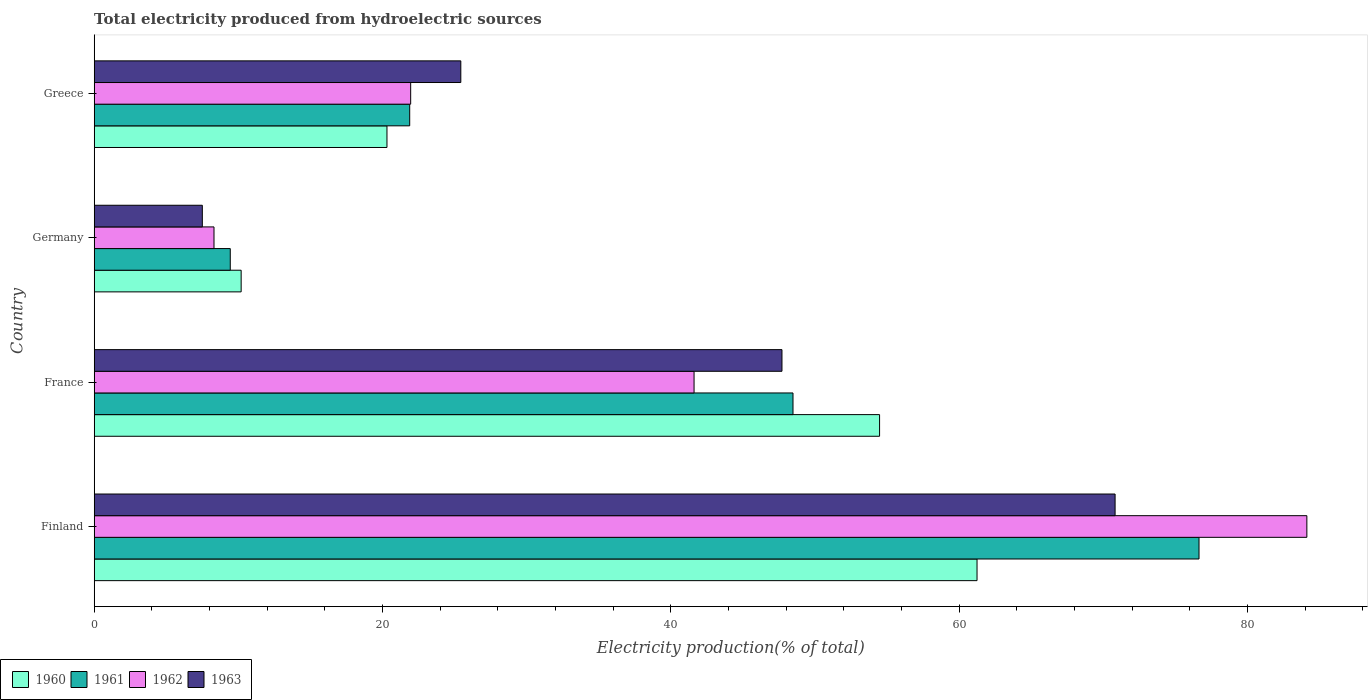How many different coloured bars are there?
Give a very brief answer. 4. Are the number of bars on each tick of the Y-axis equal?
Your response must be concise. Yes. What is the total electricity produced in 1963 in France?
Your answer should be compact. 47.7. Across all countries, what is the maximum total electricity produced in 1962?
Offer a very short reply. 84.11. Across all countries, what is the minimum total electricity produced in 1960?
Offer a very short reply. 10.19. In which country was the total electricity produced in 1961 minimum?
Offer a terse response. Germany. What is the total total electricity produced in 1963 in the graph?
Ensure brevity in your answer.  151.44. What is the difference between the total electricity produced in 1960 in Germany and that in Greece?
Your answer should be very brief. -10.11. What is the difference between the total electricity produced in 1961 in Germany and the total electricity produced in 1960 in Finland?
Make the answer very short. -51.8. What is the average total electricity produced in 1961 per country?
Ensure brevity in your answer.  39.1. What is the difference between the total electricity produced in 1963 and total electricity produced in 1961 in France?
Provide a succinct answer. -0.77. In how many countries, is the total electricity produced in 1961 greater than 72 %?
Make the answer very short. 1. What is the ratio of the total electricity produced in 1963 in France to that in Greece?
Offer a very short reply. 1.88. Is the total electricity produced in 1962 in France less than that in Germany?
Provide a succinct answer. No. What is the difference between the highest and the second highest total electricity produced in 1963?
Make the answer very short. 23.11. What is the difference between the highest and the lowest total electricity produced in 1962?
Offer a terse response. 75.8. Is the sum of the total electricity produced in 1963 in France and Germany greater than the maximum total electricity produced in 1960 across all countries?
Your answer should be very brief. No. Is it the case that in every country, the sum of the total electricity produced in 1963 and total electricity produced in 1962 is greater than the sum of total electricity produced in 1960 and total electricity produced in 1961?
Provide a short and direct response. No. Is it the case that in every country, the sum of the total electricity produced in 1963 and total electricity produced in 1961 is greater than the total electricity produced in 1960?
Your response must be concise. Yes. Are all the bars in the graph horizontal?
Provide a succinct answer. Yes. How many countries are there in the graph?
Provide a succinct answer. 4. What is the difference between two consecutive major ticks on the X-axis?
Your answer should be very brief. 20. How many legend labels are there?
Make the answer very short. 4. How are the legend labels stacked?
Give a very brief answer. Horizontal. What is the title of the graph?
Your answer should be very brief. Total electricity produced from hydroelectric sources. Does "2013" appear as one of the legend labels in the graph?
Ensure brevity in your answer.  No. What is the label or title of the X-axis?
Offer a very short reply. Electricity production(% of total). What is the label or title of the Y-axis?
Keep it short and to the point. Country. What is the Electricity production(% of total) of 1960 in Finland?
Keep it short and to the point. 61.23. What is the Electricity production(% of total) in 1961 in Finland?
Ensure brevity in your answer.  76.63. What is the Electricity production(% of total) of 1962 in Finland?
Your answer should be very brief. 84.11. What is the Electricity production(% of total) in 1963 in Finland?
Provide a succinct answer. 70.81. What is the Electricity production(% of total) of 1960 in France?
Provide a short and direct response. 54.47. What is the Electricity production(% of total) in 1961 in France?
Make the answer very short. 48.47. What is the Electricity production(% of total) in 1962 in France?
Make the answer very short. 41.61. What is the Electricity production(% of total) of 1963 in France?
Your response must be concise. 47.7. What is the Electricity production(% of total) of 1960 in Germany?
Make the answer very short. 10.19. What is the Electricity production(% of total) in 1961 in Germany?
Provide a short and direct response. 9.44. What is the Electricity production(% of total) of 1962 in Germany?
Your answer should be very brief. 8.31. What is the Electricity production(% of total) of 1963 in Germany?
Make the answer very short. 7.5. What is the Electricity production(% of total) in 1960 in Greece?
Your response must be concise. 20.31. What is the Electricity production(% of total) of 1961 in Greece?
Ensure brevity in your answer.  21.88. What is the Electricity production(% of total) of 1962 in Greece?
Provide a succinct answer. 21.95. What is the Electricity production(% of total) in 1963 in Greece?
Make the answer very short. 25.43. Across all countries, what is the maximum Electricity production(% of total) of 1960?
Offer a terse response. 61.23. Across all countries, what is the maximum Electricity production(% of total) in 1961?
Your answer should be compact. 76.63. Across all countries, what is the maximum Electricity production(% of total) in 1962?
Provide a succinct answer. 84.11. Across all countries, what is the maximum Electricity production(% of total) of 1963?
Ensure brevity in your answer.  70.81. Across all countries, what is the minimum Electricity production(% of total) in 1960?
Ensure brevity in your answer.  10.19. Across all countries, what is the minimum Electricity production(% of total) in 1961?
Provide a succinct answer. 9.44. Across all countries, what is the minimum Electricity production(% of total) of 1962?
Provide a succinct answer. 8.31. Across all countries, what is the minimum Electricity production(% of total) of 1963?
Your answer should be very brief. 7.5. What is the total Electricity production(% of total) in 1960 in the graph?
Make the answer very short. 146.2. What is the total Electricity production(% of total) of 1961 in the graph?
Provide a short and direct response. 156.42. What is the total Electricity production(% of total) of 1962 in the graph?
Provide a short and direct response. 155.97. What is the total Electricity production(% of total) in 1963 in the graph?
Provide a succinct answer. 151.44. What is the difference between the Electricity production(% of total) in 1960 in Finland and that in France?
Provide a short and direct response. 6.76. What is the difference between the Electricity production(% of total) in 1961 in Finland and that in France?
Offer a terse response. 28.16. What is the difference between the Electricity production(% of total) of 1962 in Finland and that in France?
Keep it short and to the point. 42.5. What is the difference between the Electricity production(% of total) of 1963 in Finland and that in France?
Your answer should be very brief. 23.11. What is the difference between the Electricity production(% of total) in 1960 in Finland and that in Germany?
Offer a very short reply. 51.04. What is the difference between the Electricity production(% of total) in 1961 in Finland and that in Germany?
Provide a short and direct response. 67.19. What is the difference between the Electricity production(% of total) of 1962 in Finland and that in Germany?
Give a very brief answer. 75.8. What is the difference between the Electricity production(% of total) of 1963 in Finland and that in Germany?
Your response must be concise. 63.31. What is the difference between the Electricity production(% of total) of 1960 in Finland and that in Greece?
Your answer should be very brief. 40.93. What is the difference between the Electricity production(% of total) of 1961 in Finland and that in Greece?
Provide a succinct answer. 54.75. What is the difference between the Electricity production(% of total) in 1962 in Finland and that in Greece?
Give a very brief answer. 62.16. What is the difference between the Electricity production(% of total) in 1963 in Finland and that in Greece?
Provide a short and direct response. 45.38. What is the difference between the Electricity production(% of total) of 1960 in France and that in Germany?
Give a very brief answer. 44.28. What is the difference between the Electricity production(% of total) in 1961 in France and that in Germany?
Offer a very short reply. 39.03. What is the difference between the Electricity production(% of total) in 1962 in France and that in Germany?
Ensure brevity in your answer.  33.3. What is the difference between the Electricity production(% of total) in 1963 in France and that in Germany?
Provide a succinct answer. 40.2. What is the difference between the Electricity production(% of total) in 1960 in France and that in Greece?
Your answer should be compact. 34.17. What is the difference between the Electricity production(% of total) in 1961 in France and that in Greece?
Keep it short and to the point. 26.58. What is the difference between the Electricity production(% of total) in 1962 in France and that in Greece?
Ensure brevity in your answer.  19.66. What is the difference between the Electricity production(% of total) of 1963 in France and that in Greece?
Your response must be concise. 22.27. What is the difference between the Electricity production(% of total) in 1960 in Germany and that in Greece?
Keep it short and to the point. -10.11. What is the difference between the Electricity production(% of total) of 1961 in Germany and that in Greece?
Offer a terse response. -12.45. What is the difference between the Electricity production(% of total) in 1962 in Germany and that in Greece?
Ensure brevity in your answer.  -13.64. What is the difference between the Electricity production(% of total) in 1963 in Germany and that in Greece?
Offer a terse response. -17.93. What is the difference between the Electricity production(% of total) of 1960 in Finland and the Electricity production(% of total) of 1961 in France?
Make the answer very short. 12.76. What is the difference between the Electricity production(% of total) of 1960 in Finland and the Electricity production(% of total) of 1962 in France?
Offer a terse response. 19.63. What is the difference between the Electricity production(% of total) of 1960 in Finland and the Electricity production(% of total) of 1963 in France?
Provide a succinct answer. 13.53. What is the difference between the Electricity production(% of total) of 1961 in Finland and the Electricity production(% of total) of 1962 in France?
Your answer should be compact. 35.02. What is the difference between the Electricity production(% of total) in 1961 in Finland and the Electricity production(% of total) in 1963 in France?
Make the answer very short. 28.93. What is the difference between the Electricity production(% of total) in 1962 in Finland and the Electricity production(% of total) in 1963 in France?
Offer a terse response. 36.41. What is the difference between the Electricity production(% of total) in 1960 in Finland and the Electricity production(% of total) in 1961 in Germany?
Give a very brief answer. 51.8. What is the difference between the Electricity production(% of total) of 1960 in Finland and the Electricity production(% of total) of 1962 in Germany?
Provide a succinct answer. 52.92. What is the difference between the Electricity production(% of total) in 1960 in Finland and the Electricity production(% of total) in 1963 in Germany?
Your answer should be compact. 53.73. What is the difference between the Electricity production(% of total) of 1961 in Finland and the Electricity production(% of total) of 1962 in Germany?
Give a very brief answer. 68.32. What is the difference between the Electricity production(% of total) of 1961 in Finland and the Electricity production(% of total) of 1963 in Germany?
Make the answer very short. 69.13. What is the difference between the Electricity production(% of total) in 1962 in Finland and the Electricity production(% of total) in 1963 in Germany?
Your answer should be very brief. 76.61. What is the difference between the Electricity production(% of total) in 1960 in Finland and the Electricity production(% of total) in 1961 in Greece?
Your response must be concise. 39.35. What is the difference between the Electricity production(% of total) in 1960 in Finland and the Electricity production(% of total) in 1962 in Greece?
Offer a terse response. 39.28. What is the difference between the Electricity production(% of total) in 1960 in Finland and the Electricity production(% of total) in 1963 in Greece?
Ensure brevity in your answer.  35.8. What is the difference between the Electricity production(% of total) in 1961 in Finland and the Electricity production(% of total) in 1962 in Greece?
Your answer should be very brief. 54.68. What is the difference between the Electricity production(% of total) in 1961 in Finland and the Electricity production(% of total) in 1963 in Greece?
Offer a terse response. 51.2. What is the difference between the Electricity production(% of total) in 1962 in Finland and the Electricity production(% of total) in 1963 in Greece?
Provide a succinct answer. 58.68. What is the difference between the Electricity production(% of total) in 1960 in France and the Electricity production(% of total) in 1961 in Germany?
Offer a terse response. 45.04. What is the difference between the Electricity production(% of total) of 1960 in France and the Electricity production(% of total) of 1962 in Germany?
Make the answer very short. 46.16. What is the difference between the Electricity production(% of total) in 1960 in France and the Electricity production(% of total) in 1963 in Germany?
Your response must be concise. 46.97. What is the difference between the Electricity production(% of total) in 1961 in France and the Electricity production(% of total) in 1962 in Germany?
Your response must be concise. 40.16. What is the difference between the Electricity production(% of total) of 1961 in France and the Electricity production(% of total) of 1963 in Germany?
Give a very brief answer. 40.97. What is the difference between the Electricity production(% of total) in 1962 in France and the Electricity production(% of total) in 1963 in Germany?
Provide a short and direct response. 34.11. What is the difference between the Electricity production(% of total) in 1960 in France and the Electricity production(% of total) in 1961 in Greece?
Give a very brief answer. 32.59. What is the difference between the Electricity production(% of total) of 1960 in France and the Electricity production(% of total) of 1962 in Greece?
Make the answer very short. 32.52. What is the difference between the Electricity production(% of total) of 1960 in France and the Electricity production(% of total) of 1963 in Greece?
Offer a very short reply. 29.05. What is the difference between the Electricity production(% of total) in 1961 in France and the Electricity production(% of total) in 1962 in Greece?
Provide a succinct answer. 26.52. What is the difference between the Electricity production(% of total) of 1961 in France and the Electricity production(% of total) of 1963 in Greece?
Give a very brief answer. 23.04. What is the difference between the Electricity production(% of total) in 1962 in France and the Electricity production(% of total) in 1963 in Greece?
Keep it short and to the point. 16.18. What is the difference between the Electricity production(% of total) in 1960 in Germany and the Electricity production(% of total) in 1961 in Greece?
Ensure brevity in your answer.  -11.69. What is the difference between the Electricity production(% of total) in 1960 in Germany and the Electricity production(% of total) in 1962 in Greece?
Provide a short and direct response. -11.76. What is the difference between the Electricity production(% of total) of 1960 in Germany and the Electricity production(% of total) of 1963 in Greece?
Offer a terse response. -15.24. What is the difference between the Electricity production(% of total) of 1961 in Germany and the Electricity production(% of total) of 1962 in Greece?
Ensure brevity in your answer.  -12.51. What is the difference between the Electricity production(% of total) in 1961 in Germany and the Electricity production(% of total) in 1963 in Greece?
Provide a succinct answer. -15.99. What is the difference between the Electricity production(% of total) in 1962 in Germany and the Electricity production(% of total) in 1963 in Greece?
Give a very brief answer. -17.12. What is the average Electricity production(% of total) in 1960 per country?
Provide a succinct answer. 36.55. What is the average Electricity production(% of total) of 1961 per country?
Offer a terse response. 39.1. What is the average Electricity production(% of total) of 1962 per country?
Make the answer very short. 38.99. What is the average Electricity production(% of total) in 1963 per country?
Provide a short and direct response. 37.86. What is the difference between the Electricity production(% of total) in 1960 and Electricity production(% of total) in 1961 in Finland?
Provide a succinct answer. -15.4. What is the difference between the Electricity production(% of total) in 1960 and Electricity production(% of total) in 1962 in Finland?
Offer a very short reply. -22.88. What is the difference between the Electricity production(% of total) of 1960 and Electricity production(% of total) of 1963 in Finland?
Give a very brief answer. -9.58. What is the difference between the Electricity production(% of total) in 1961 and Electricity production(% of total) in 1962 in Finland?
Give a very brief answer. -7.48. What is the difference between the Electricity production(% of total) in 1961 and Electricity production(% of total) in 1963 in Finland?
Make the answer very short. 5.82. What is the difference between the Electricity production(% of total) in 1962 and Electricity production(% of total) in 1963 in Finland?
Ensure brevity in your answer.  13.3. What is the difference between the Electricity production(% of total) of 1960 and Electricity production(% of total) of 1961 in France?
Offer a terse response. 6.01. What is the difference between the Electricity production(% of total) of 1960 and Electricity production(% of total) of 1962 in France?
Make the answer very short. 12.87. What is the difference between the Electricity production(% of total) of 1960 and Electricity production(% of total) of 1963 in France?
Provide a succinct answer. 6.77. What is the difference between the Electricity production(% of total) of 1961 and Electricity production(% of total) of 1962 in France?
Keep it short and to the point. 6.86. What is the difference between the Electricity production(% of total) of 1961 and Electricity production(% of total) of 1963 in France?
Your answer should be very brief. 0.77. What is the difference between the Electricity production(% of total) of 1962 and Electricity production(% of total) of 1963 in France?
Offer a terse response. -6.1. What is the difference between the Electricity production(% of total) of 1960 and Electricity production(% of total) of 1961 in Germany?
Ensure brevity in your answer.  0.76. What is the difference between the Electricity production(% of total) in 1960 and Electricity production(% of total) in 1962 in Germany?
Keep it short and to the point. 1.88. What is the difference between the Electricity production(% of total) in 1960 and Electricity production(% of total) in 1963 in Germany?
Provide a succinct answer. 2.69. What is the difference between the Electricity production(% of total) of 1961 and Electricity production(% of total) of 1962 in Germany?
Provide a short and direct response. 1.13. What is the difference between the Electricity production(% of total) of 1961 and Electricity production(% of total) of 1963 in Germany?
Keep it short and to the point. 1.94. What is the difference between the Electricity production(% of total) of 1962 and Electricity production(% of total) of 1963 in Germany?
Your answer should be very brief. 0.81. What is the difference between the Electricity production(% of total) in 1960 and Electricity production(% of total) in 1961 in Greece?
Provide a succinct answer. -1.58. What is the difference between the Electricity production(% of total) in 1960 and Electricity production(% of total) in 1962 in Greece?
Your answer should be very brief. -1.64. What is the difference between the Electricity production(% of total) of 1960 and Electricity production(% of total) of 1963 in Greece?
Keep it short and to the point. -5.12. What is the difference between the Electricity production(% of total) of 1961 and Electricity production(% of total) of 1962 in Greece?
Your response must be concise. -0.07. What is the difference between the Electricity production(% of total) in 1961 and Electricity production(% of total) in 1963 in Greece?
Ensure brevity in your answer.  -3.54. What is the difference between the Electricity production(% of total) in 1962 and Electricity production(% of total) in 1963 in Greece?
Make the answer very short. -3.48. What is the ratio of the Electricity production(% of total) in 1960 in Finland to that in France?
Make the answer very short. 1.12. What is the ratio of the Electricity production(% of total) in 1961 in Finland to that in France?
Keep it short and to the point. 1.58. What is the ratio of the Electricity production(% of total) in 1962 in Finland to that in France?
Offer a terse response. 2.02. What is the ratio of the Electricity production(% of total) in 1963 in Finland to that in France?
Your answer should be compact. 1.48. What is the ratio of the Electricity production(% of total) of 1960 in Finland to that in Germany?
Ensure brevity in your answer.  6.01. What is the ratio of the Electricity production(% of total) in 1961 in Finland to that in Germany?
Give a very brief answer. 8.12. What is the ratio of the Electricity production(% of total) in 1962 in Finland to that in Germany?
Your answer should be compact. 10.12. What is the ratio of the Electricity production(% of total) of 1963 in Finland to that in Germany?
Provide a short and direct response. 9.44. What is the ratio of the Electricity production(% of total) of 1960 in Finland to that in Greece?
Offer a very short reply. 3.02. What is the ratio of the Electricity production(% of total) in 1961 in Finland to that in Greece?
Ensure brevity in your answer.  3.5. What is the ratio of the Electricity production(% of total) of 1962 in Finland to that in Greece?
Offer a terse response. 3.83. What is the ratio of the Electricity production(% of total) of 1963 in Finland to that in Greece?
Your answer should be very brief. 2.78. What is the ratio of the Electricity production(% of total) in 1960 in France to that in Germany?
Your response must be concise. 5.34. What is the ratio of the Electricity production(% of total) in 1961 in France to that in Germany?
Give a very brief answer. 5.14. What is the ratio of the Electricity production(% of total) in 1962 in France to that in Germany?
Offer a terse response. 5.01. What is the ratio of the Electricity production(% of total) in 1963 in France to that in Germany?
Ensure brevity in your answer.  6.36. What is the ratio of the Electricity production(% of total) in 1960 in France to that in Greece?
Make the answer very short. 2.68. What is the ratio of the Electricity production(% of total) of 1961 in France to that in Greece?
Keep it short and to the point. 2.21. What is the ratio of the Electricity production(% of total) in 1962 in France to that in Greece?
Your response must be concise. 1.9. What is the ratio of the Electricity production(% of total) of 1963 in France to that in Greece?
Provide a short and direct response. 1.88. What is the ratio of the Electricity production(% of total) in 1960 in Germany to that in Greece?
Provide a short and direct response. 0.5. What is the ratio of the Electricity production(% of total) in 1961 in Germany to that in Greece?
Your answer should be very brief. 0.43. What is the ratio of the Electricity production(% of total) in 1962 in Germany to that in Greece?
Offer a very short reply. 0.38. What is the ratio of the Electricity production(% of total) of 1963 in Germany to that in Greece?
Keep it short and to the point. 0.29. What is the difference between the highest and the second highest Electricity production(% of total) in 1960?
Offer a terse response. 6.76. What is the difference between the highest and the second highest Electricity production(% of total) of 1961?
Provide a short and direct response. 28.16. What is the difference between the highest and the second highest Electricity production(% of total) of 1962?
Make the answer very short. 42.5. What is the difference between the highest and the second highest Electricity production(% of total) in 1963?
Your response must be concise. 23.11. What is the difference between the highest and the lowest Electricity production(% of total) in 1960?
Your answer should be compact. 51.04. What is the difference between the highest and the lowest Electricity production(% of total) in 1961?
Your response must be concise. 67.19. What is the difference between the highest and the lowest Electricity production(% of total) in 1962?
Your response must be concise. 75.8. What is the difference between the highest and the lowest Electricity production(% of total) in 1963?
Your response must be concise. 63.31. 